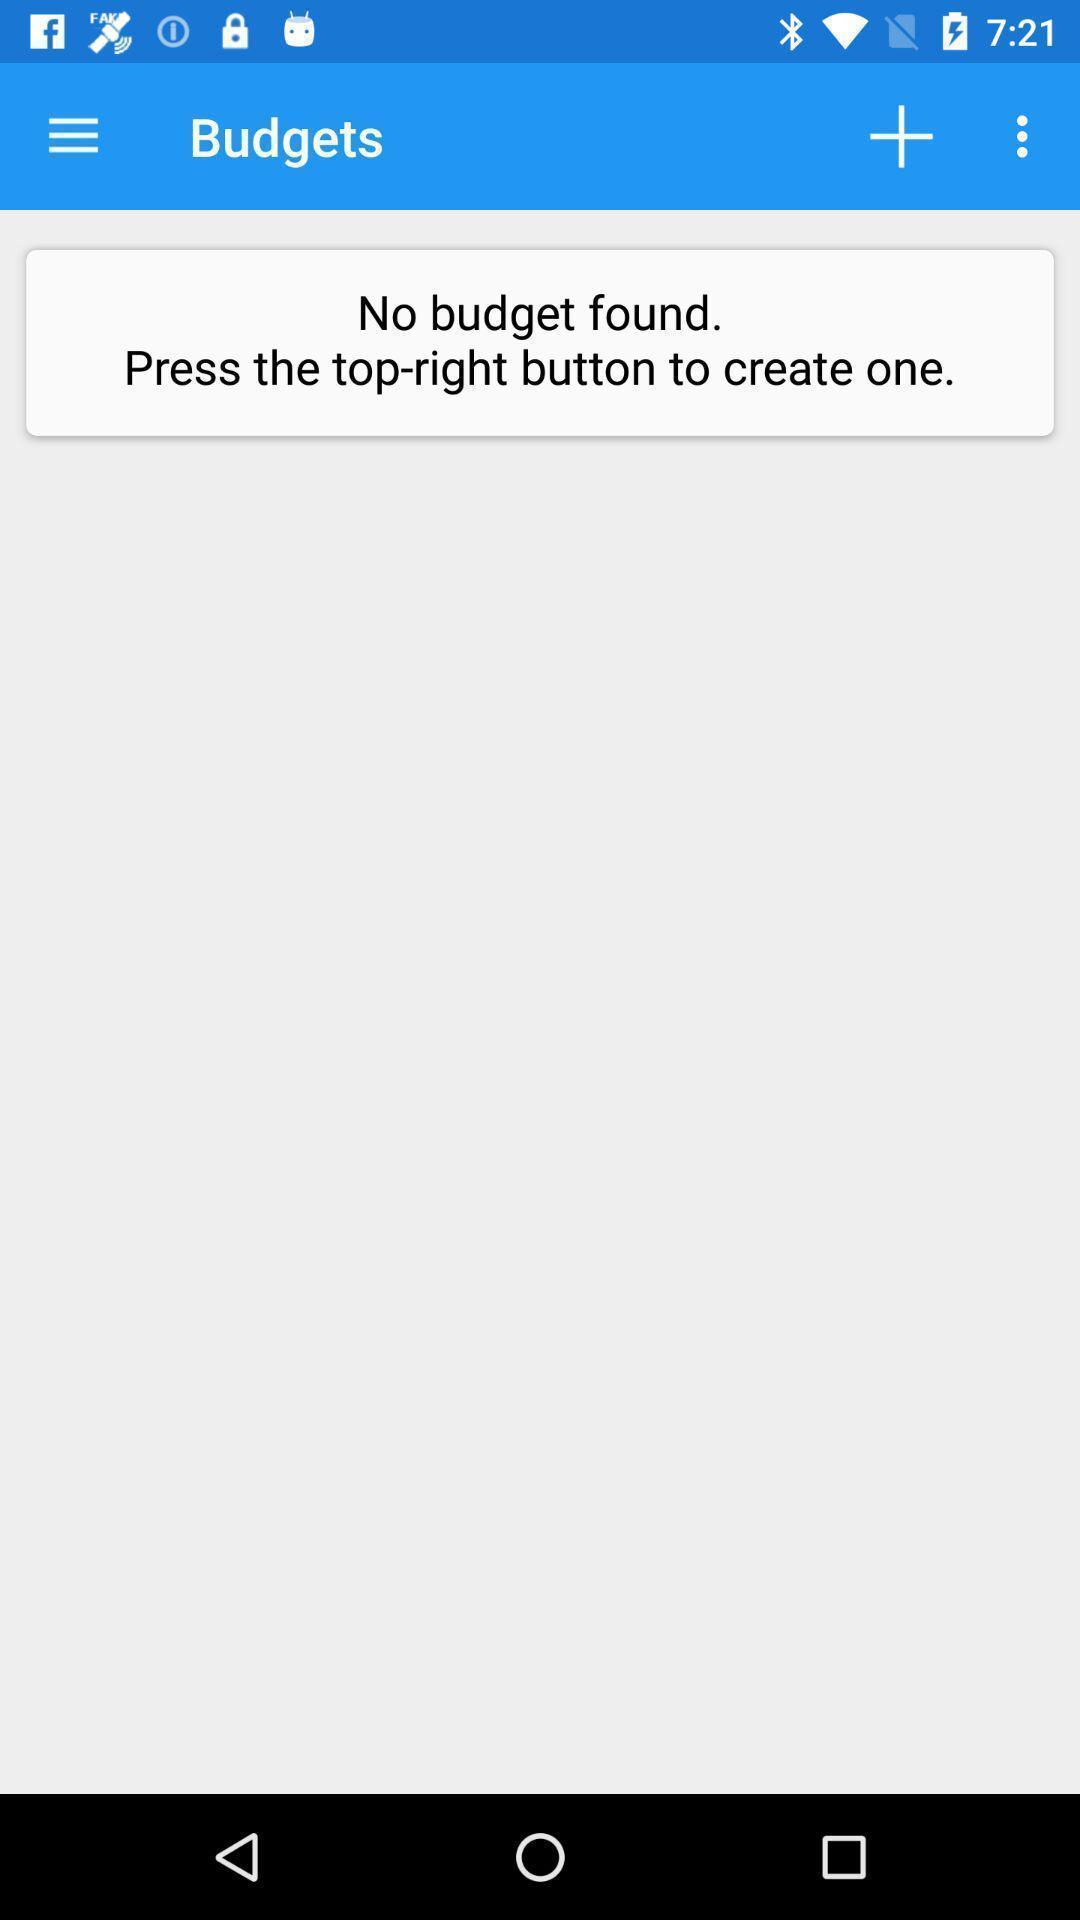Describe this image in words. Page showing the interface of a financial app. 